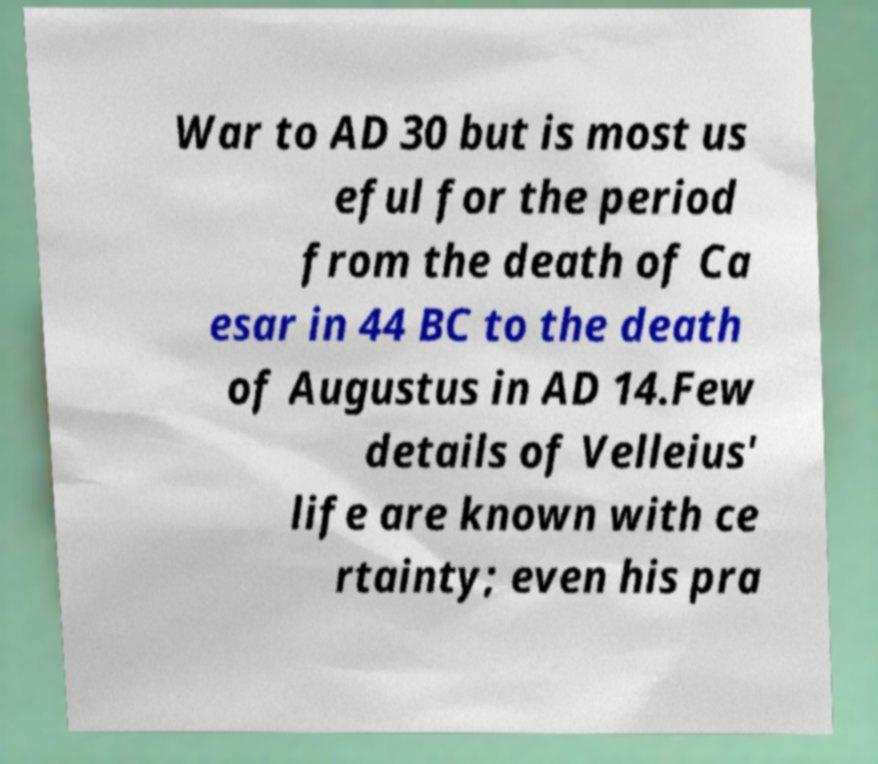I need the written content from this picture converted into text. Can you do that? War to AD 30 but is most us eful for the period from the death of Ca esar in 44 BC to the death of Augustus in AD 14.Few details of Velleius' life are known with ce rtainty; even his pra 